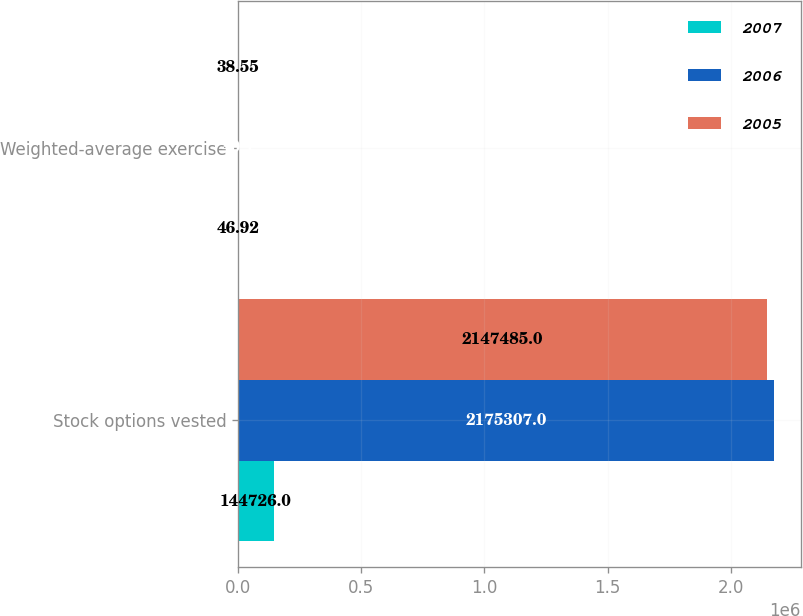<chart> <loc_0><loc_0><loc_500><loc_500><stacked_bar_chart><ecel><fcel>Stock options vested<fcel>Weighted-average exercise<nl><fcel>2007<fcel>144726<fcel>46.92<nl><fcel>2006<fcel>2.17531e+06<fcel>40.1<nl><fcel>2005<fcel>2.14748e+06<fcel>38.55<nl></chart> 